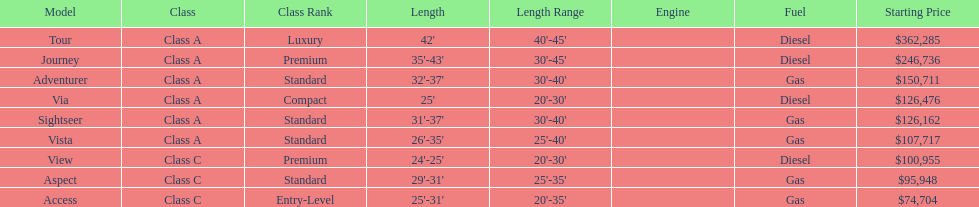Could you parse the entire table as a dict? {'header': ['Model', 'Class', 'Class Rank', 'Length', 'Length Range', 'Engine', 'Fuel', 'Starting Price'], 'rows': [['Tour', 'Class A', 'Luxury', "42'", "40'-45'", '', 'Diesel', '$362,285'], ['Journey', 'Class A', 'Premium', "35'-43'", "30'-45'", '', 'Diesel', '$246,736'], ['Adventurer', 'Class A', 'Standard', "32'-37'", "30'-40'", '', 'Gas', '$150,711'], ['Via', 'Class A', 'Compact', "25'", "20'-30'", '', 'Diesel', '$126,476'], ['Sightseer', 'Class A', 'Standard', "31'-37'", "30'-40'", '', 'Gas', '$126,162'], ['Vista', 'Class A', 'Standard', "26'-35'", "25'-40'", '', 'Gas', '$107,717'], ['View', 'Class C', 'Premium', "24'-25'", "20'-30'", '', 'Diesel', '$100,955'], ['Aspect', 'Class C', 'Standard', "29'-31'", "25'-35'", '', 'Gas', '$95,948'], ['Access', 'Class C', 'Entry-Level', "25'-31'", "20'-35'", '', 'Gas', '$74,704']]} Which model is at the top of the list with the highest starting price? Tour. 